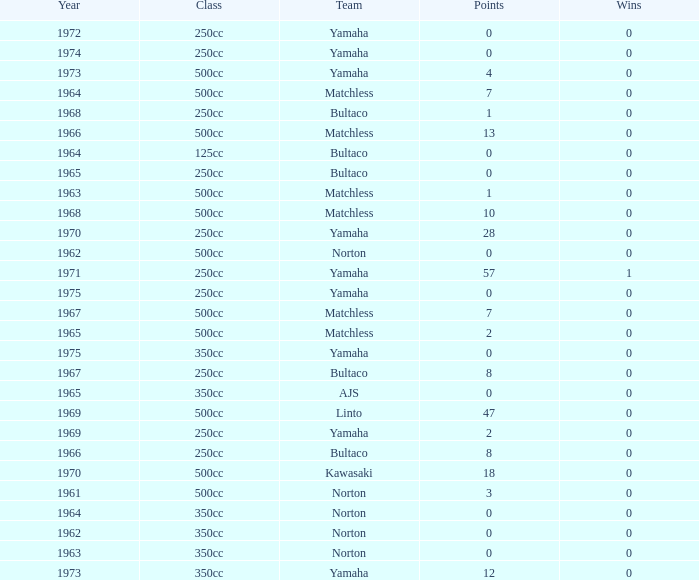Which class corresponds to more than 2 points, wins greater than 0, and a year earlier than 1973? 250cc. 